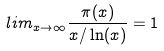Convert formula to latex. <formula><loc_0><loc_0><loc_500><loc_500>l i m _ { x \rightarrow \infty } \frac { \pi ( x ) } { x / \ln ( x ) } = 1</formula> 